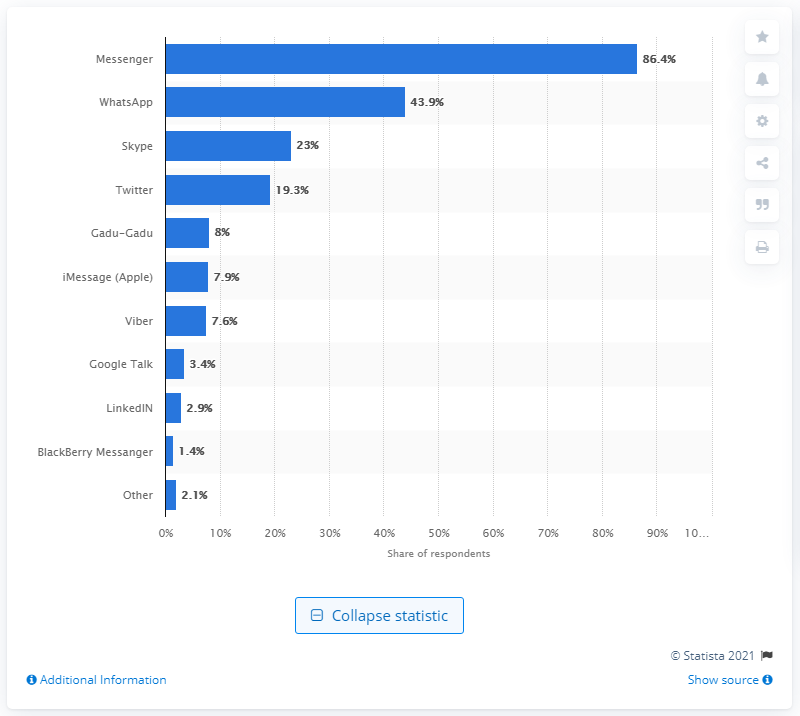Point out several critical features in this image. The Polish instant messaging client is called Gadu-Gadu. In 2019, it was found that 86.4% of Polish people used the Messenger app. 